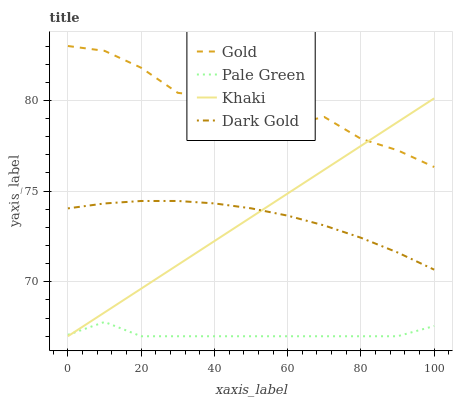Does Pale Green have the minimum area under the curve?
Answer yes or no. Yes. Does Gold have the maximum area under the curve?
Answer yes or no. Yes. Does Khaki have the minimum area under the curve?
Answer yes or no. No. Does Khaki have the maximum area under the curve?
Answer yes or no. No. Is Khaki the smoothest?
Answer yes or no. Yes. Is Gold the roughest?
Answer yes or no. Yes. Is Gold the smoothest?
Answer yes or no. No. Is Khaki the roughest?
Answer yes or no. No. Does Gold have the lowest value?
Answer yes or no. No. Does Khaki have the highest value?
Answer yes or no. No. Is Pale Green less than Gold?
Answer yes or no. Yes. Is Gold greater than Dark Gold?
Answer yes or no. Yes. Does Pale Green intersect Gold?
Answer yes or no. No. 